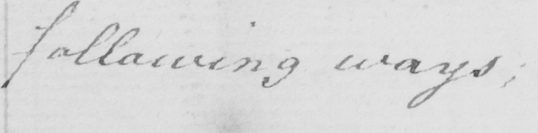Transcribe the text shown in this historical manuscript line. following ways ; 